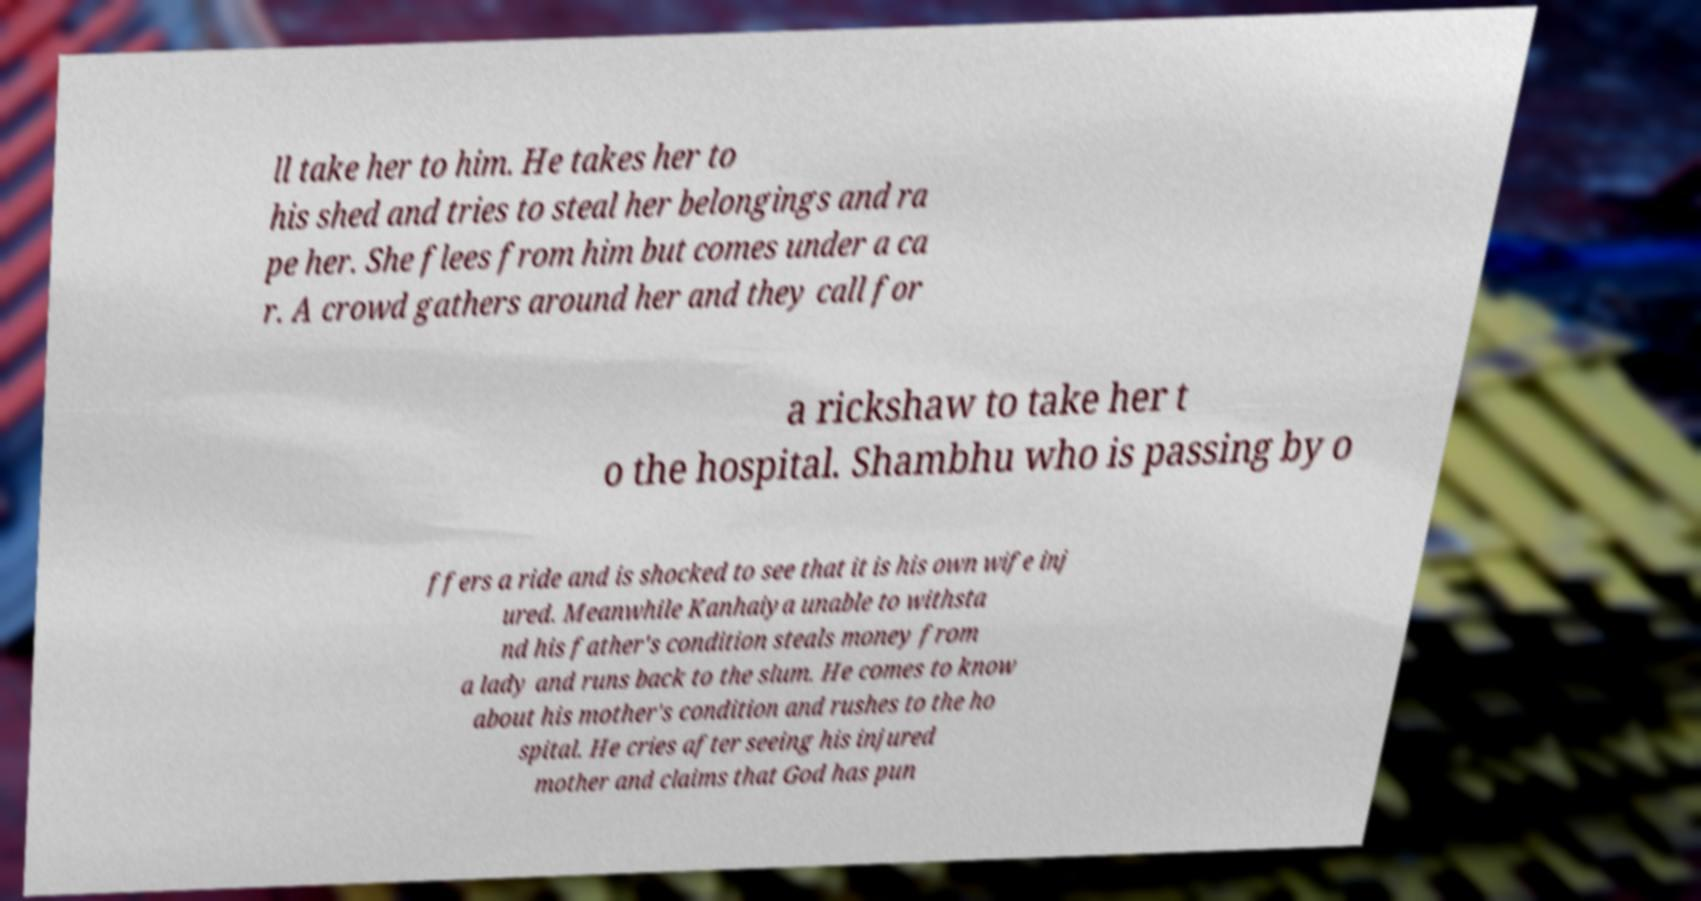What messages or text are displayed in this image? I need them in a readable, typed format. ll take her to him. He takes her to his shed and tries to steal her belongings and ra pe her. She flees from him but comes under a ca r. A crowd gathers around her and they call for a rickshaw to take her t o the hospital. Shambhu who is passing by o ffers a ride and is shocked to see that it is his own wife inj ured. Meanwhile Kanhaiya unable to withsta nd his father's condition steals money from a lady and runs back to the slum. He comes to know about his mother's condition and rushes to the ho spital. He cries after seeing his injured mother and claims that God has pun 